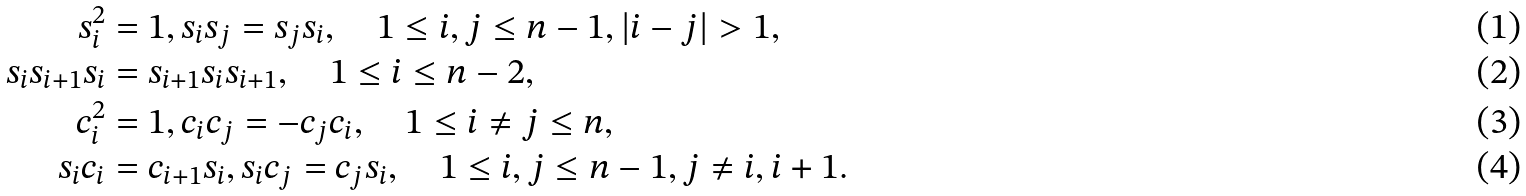Convert formula to latex. <formula><loc_0><loc_0><loc_500><loc_500>s _ { i } ^ { 2 } & = 1 , s _ { i } s _ { j } = s _ { j } s _ { i } , \quad 1 \leq i , j \leq n - 1 , | i - j | > 1 , \\ s _ { i } s _ { i + 1 } s _ { i } & = s _ { i + 1 } s _ { i } s _ { i + 1 } , \quad 1 \leq i \leq n - 2 , \\ c _ { i } ^ { 2 } & = 1 , c _ { i } c _ { j } = - c _ { j } c _ { i } , \quad 1 \leq i \neq j \leq n , \\ s _ { i } c _ { i } & = c _ { i + 1 } s _ { i } , s _ { i } c _ { j } = c _ { j } s _ { i } , \quad 1 \leq i , j \leq n - 1 , j \neq i , i + 1 .</formula> 